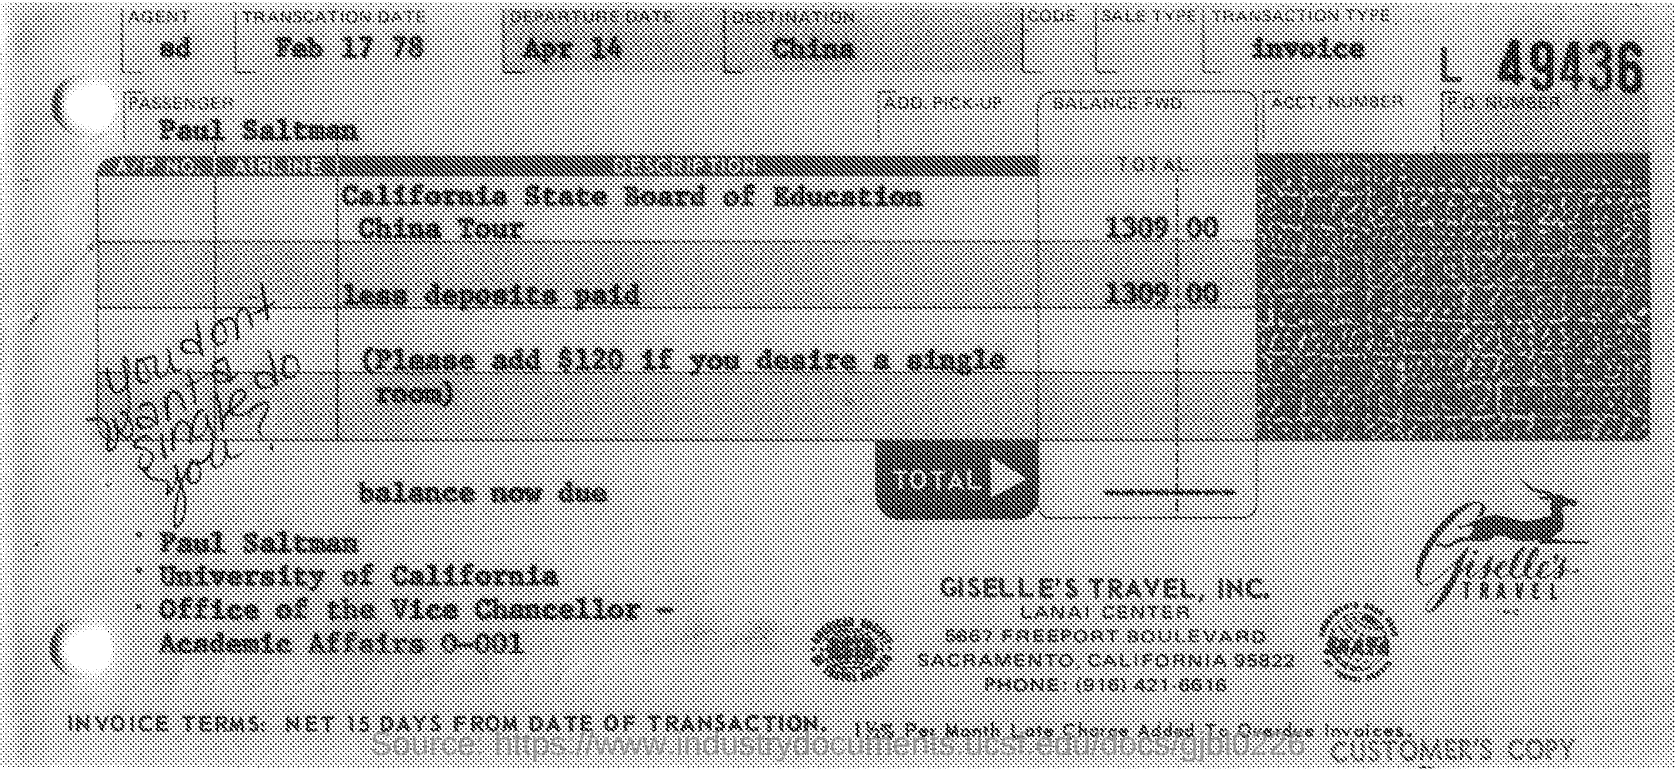What is the  transcation date mentioned in the given page ?
Give a very brief answer. Feb 17 78. What is the departure date mentioned in the given page ?
Provide a succinct answer. APR 14. What is the place of destination mentioned in the given page ?
Your answer should be compact. China. What is the transcation type mentioned in the given page ?
Your response must be concise. Invoice. What is the name of the passenger mentioned in the given page ?
Offer a terse response. Paul saltman. What is the name of the travel mentioned in the given page ?
Ensure brevity in your answer.  Giselle's travel, inc. To which university paul salt man belongs to as mentioned in the given page ?
Offer a terse response. University of california. 